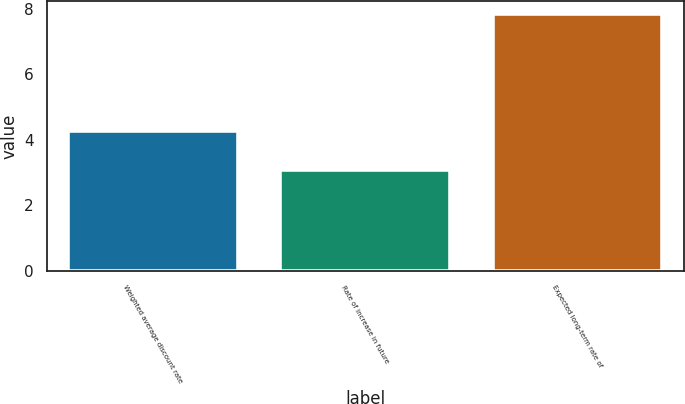<chart> <loc_0><loc_0><loc_500><loc_500><bar_chart><fcel>Weighted average discount rate<fcel>Rate of increase in future<fcel>Expected long-term rate of<nl><fcel>4.26<fcel>3.07<fcel>7.85<nl></chart> 